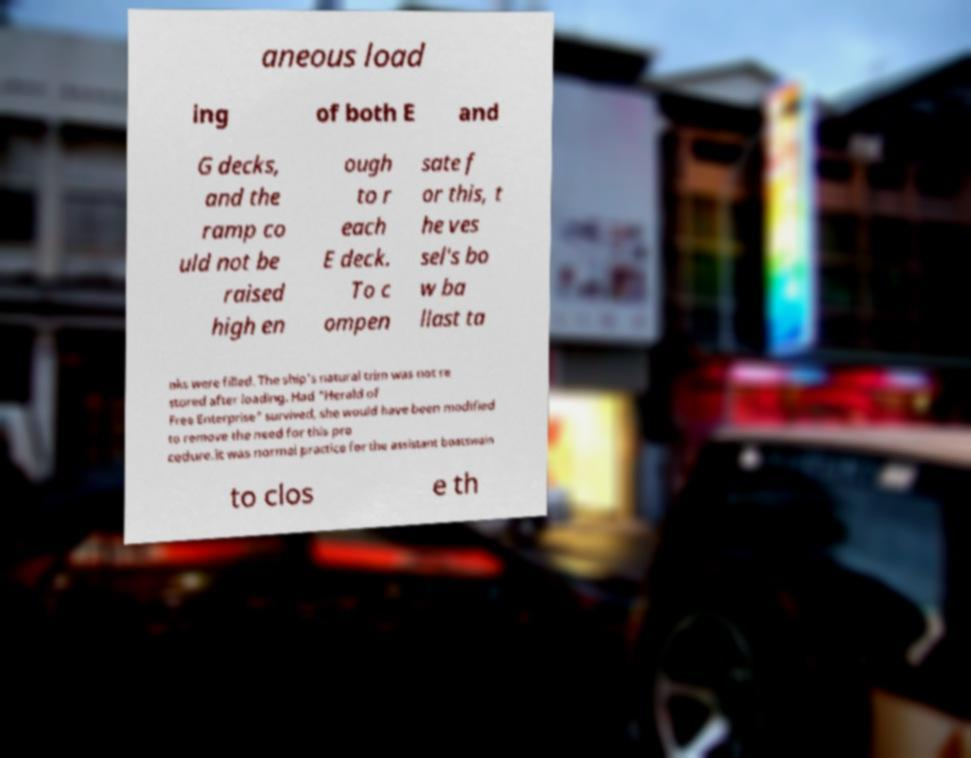Can you read and provide the text displayed in the image?This photo seems to have some interesting text. Can you extract and type it out for me? aneous load ing of both E and G decks, and the ramp co uld not be raised high en ough to r each E deck. To c ompen sate f or this, t he ves sel's bo w ba llast ta nks were filled. The ship's natural trim was not re stored after loading. Had "Herald of Free Enterprise" survived, she would have been modified to remove the need for this pro cedure.It was normal practice for the assistant boatswain to clos e th 